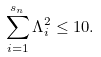<formula> <loc_0><loc_0><loc_500><loc_500>\sum _ { i = 1 } ^ { s _ { n } } \Lambda _ { i } ^ { 2 } \leq 1 0 .</formula> 